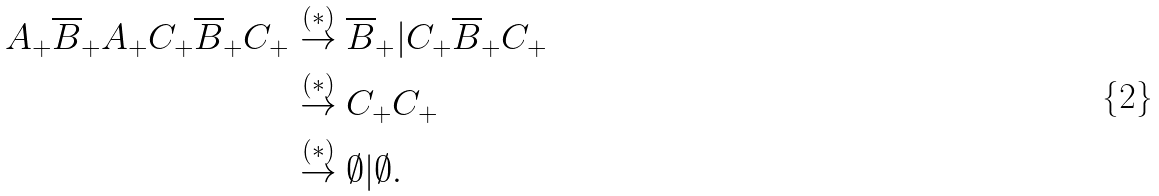Convert formula to latex. <formula><loc_0><loc_0><loc_500><loc_500>A _ { + } \overline { B } _ { + } A _ { + } C _ { + } \overline { B } _ { + } C _ { + } & \stackrel { ( \ast ) } { \rightarrow } \overline { B } _ { + } | C _ { + } \overline { B } _ { + } C _ { + } \\ & \stackrel { ( \ast ) } { \rightarrow } C _ { + } C _ { + } \\ & \stackrel { ( \ast ) } { \rightarrow } \emptyset | \emptyset .</formula> 